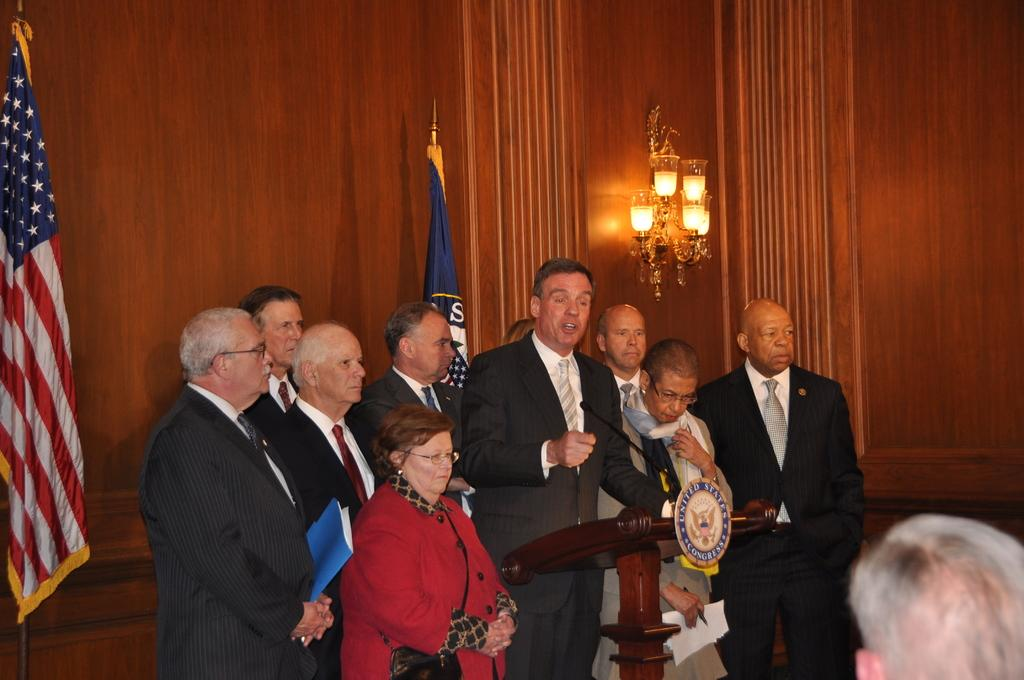What is happening in the center of the image? There are many people standing on the ground in the center of the image. What can be seen in the background of the image? There are flags, a wall, and lights in the background of the image. Are there any representatives from the school in the image? There is no mention of a school or any representatives in the image. Can you tell me how many people are flying in the image? There are no people flying in the image; everyone is standing on the ground. 